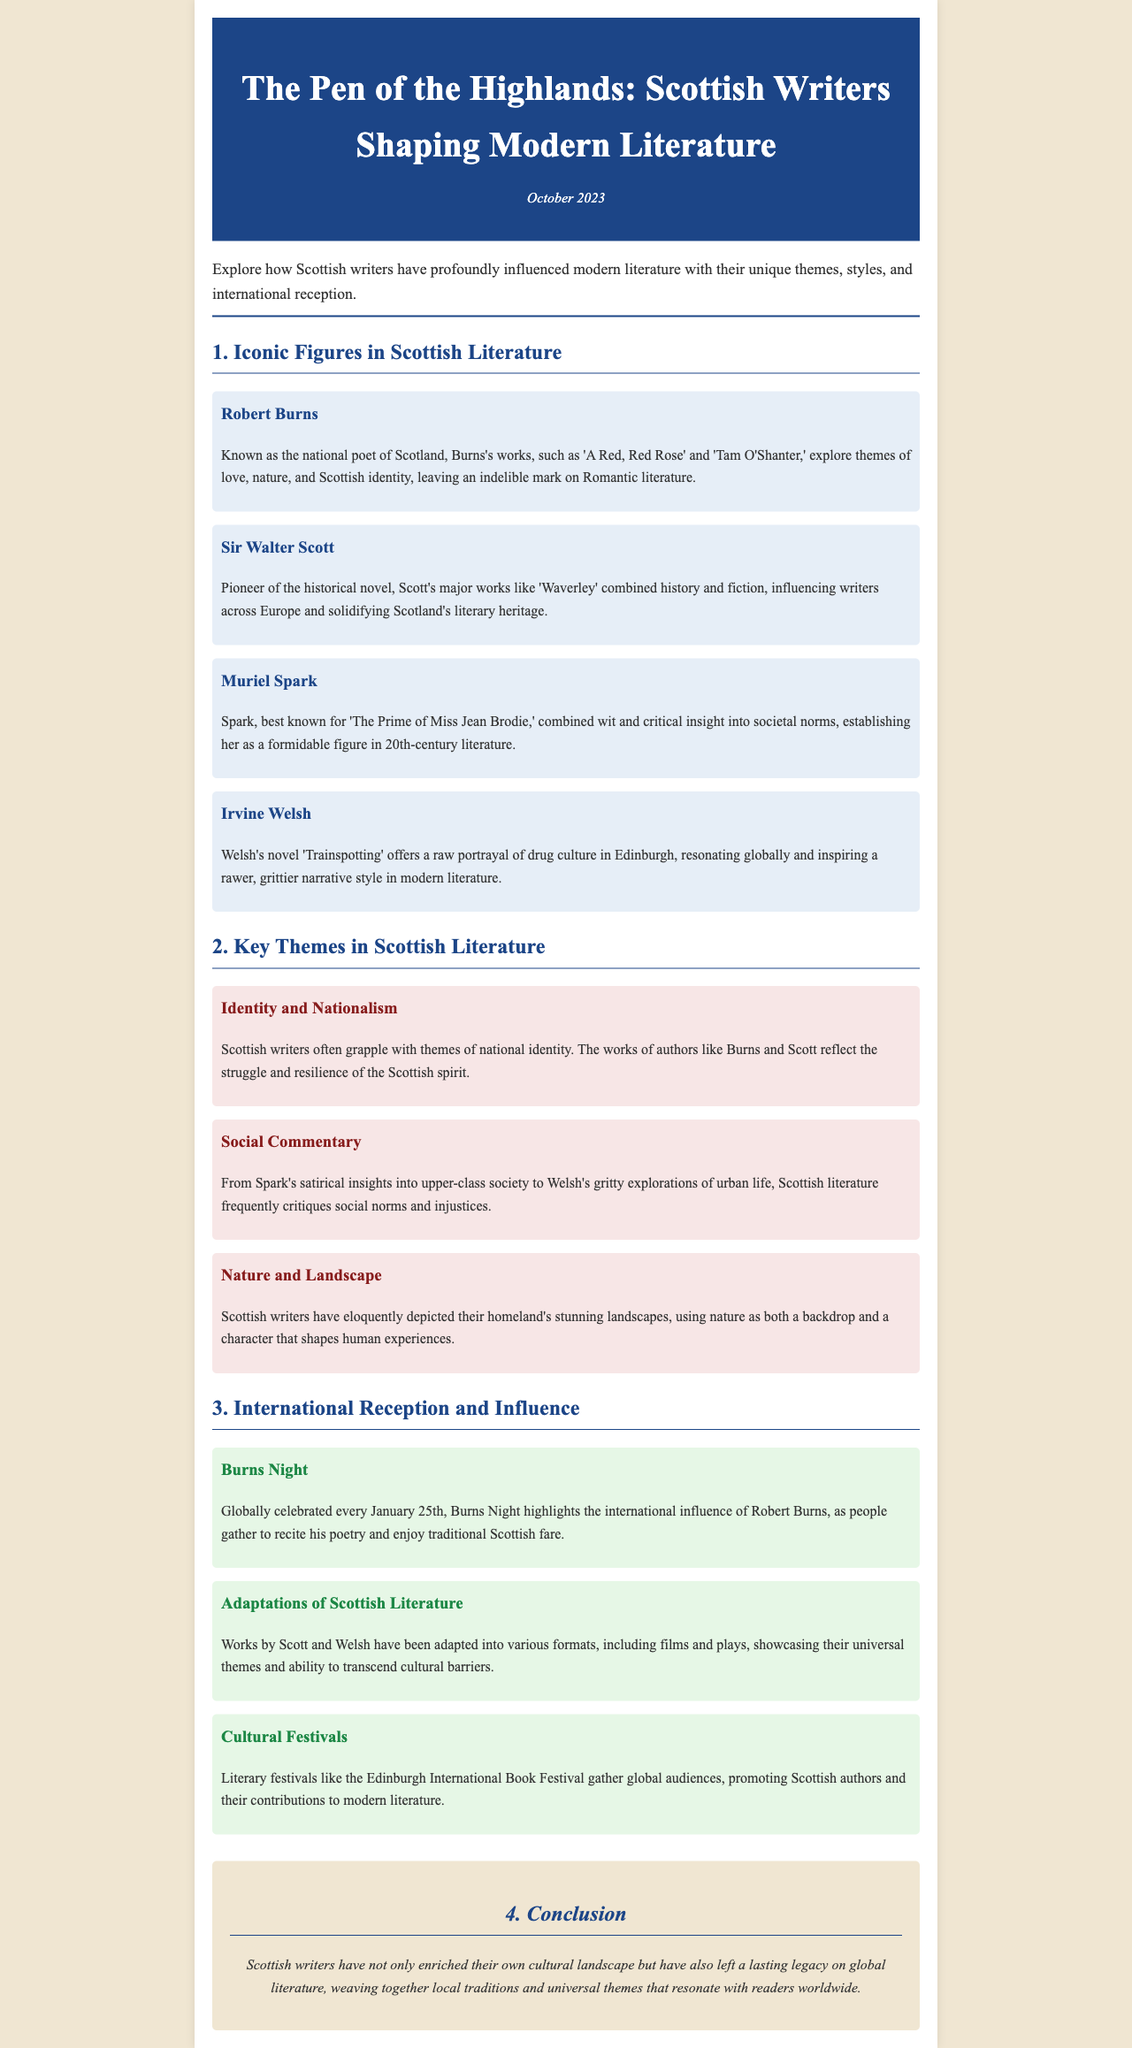What is the title of the newsletter? The title is clearly stated in the header of the document.
Answer: The Pen of the Highlands: Scottish Writers Shaping Modern Literature Who is known as the national poet of Scotland? The document introduces Robert Burns as the national poet in the section about iconic figures.
Answer: Robert Burns Which novel is Muriel Spark best known for? The document specifies Spark's most recognized work within her biography.
Answer: The Prime of Miss Jean Brodie What theme is associated with Irvine Welsh's writing? The document highlights the themes explored in Welsh's novel, giving insight into his style.
Answer: Drug culture When is Burns Night celebrated? The document provides the specific date of the global celebration of Robert Burns's influence.
Answer: January 25th What kind of adaptations have been made from works by Scott and Welsh? The document discusses adaptations in various formats, highlighting their influence.
Answer: Films and plays Which festival promotes Scottish authors globally? The document mentions a prominent festival that showcases Scottish literary contributions.
Answer: Edinburgh International Book Festival What theme is emphasized in the works of Burns and Scott? The document identifies a common theme related to Scottish writers' exploration of their identity.
Answer: National identity What characterizes the landscape descriptions in Scottish literature? The document notes a common trait in the depiction of landscapes by Scottish writers.
Answer: Stunning landscapes 